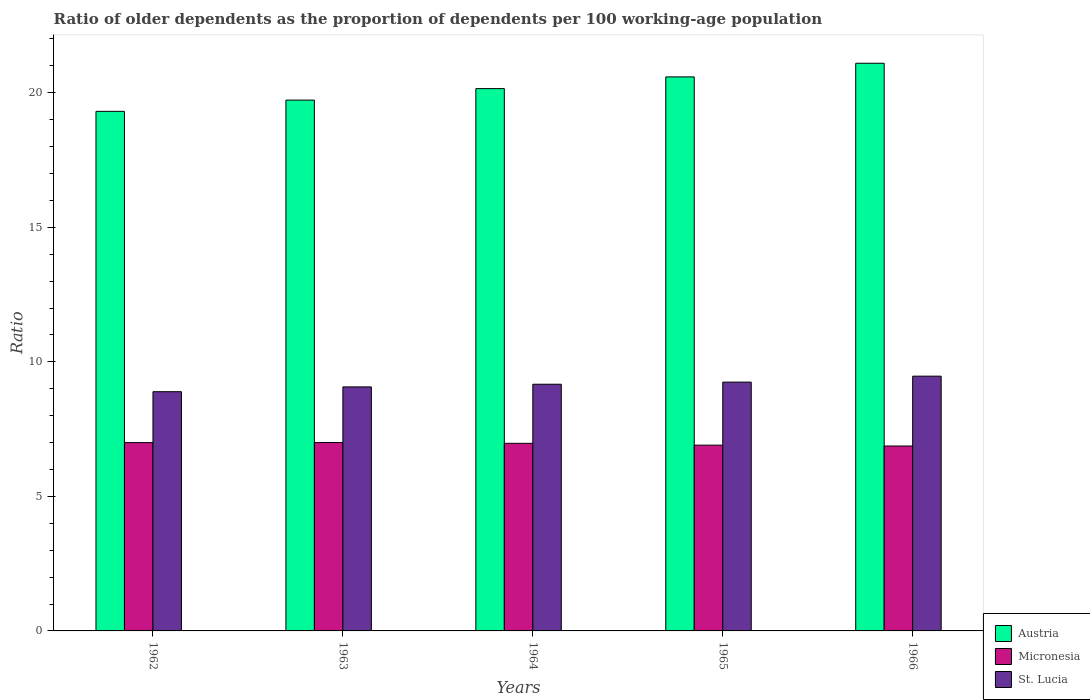How many different coloured bars are there?
Your answer should be very brief. 3. Are the number of bars per tick equal to the number of legend labels?
Offer a very short reply. Yes. Are the number of bars on each tick of the X-axis equal?
Your response must be concise. Yes. How many bars are there on the 2nd tick from the left?
Ensure brevity in your answer.  3. How many bars are there on the 3rd tick from the right?
Provide a short and direct response. 3. What is the label of the 4th group of bars from the left?
Your answer should be compact. 1965. What is the age dependency ratio(old) in Austria in 1965?
Offer a very short reply. 20.59. Across all years, what is the maximum age dependency ratio(old) in Micronesia?
Your answer should be compact. 7. Across all years, what is the minimum age dependency ratio(old) in St. Lucia?
Your answer should be very brief. 8.89. In which year was the age dependency ratio(old) in St. Lucia maximum?
Provide a short and direct response. 1966. What is the total age dependency ratio(old) in Austria in the graph?
Offer a terse response. 100.87. What is the difference between the age dependency ratio(old) in Austria in 1963 and that in 1964?
Ensure brevity in your answer.  -0.43. What is the difference between the age dependency ratio(old) in St. Lucia in 1966 and the age dependency ratio(old) in Austria in 1963?
Provide a short and direct response. -10.26. What is the average age dependency ratio(old) in Micronesia per year?
Your answer should be very brief. 6.95. In the year 1966, what is the difference between the age dependency ratio(old) in Austria and age dependency ratio(old) in Micronesia?
Keep it short and to the point. 14.22. In how many years, is the age dependency ratio(old) in Micronesia greater than 8?
Make the answer very short. 0. What is the ratio of the age dependency ratio(old) in Austria in 1962 to that in 1963?
Provide a short and direct response. 0.98. Is the age dependency ratio(old) in Micronesia in 1964 less than that in 1965?
Offer a terse response. No. Is the difference between the age dependency ratio(old) in Austria in 1964 and 1966 greater than the difference between the age dependency ratio(old) in Micronesia in 1964 and 1966?
Offer a terse response. No. What is the difference between the highest and the second highest age dependency ratio(old) in Micronesia?
Give a very brief answer. 0. What is the difference between the highest and the lowest age dependency ratio(old) in Micronesia?
Make the answer very short. 0.13. What does the 1st bar from the right in 1962 represents?
Make the answer very short. St. Lucia. Is it the case that in every year, the sum of the age dependency ratio(old) in Austria and age dependency ratio(old) in St. Lucia is greater than the age dependency ratio(old) in Micronesia?
Ensure brevity in your answer.  Yes. How many bars are there?
Your answer should be compact. 15. How many years are there in the graph?
Ensure brevity in your answer.  5. What is the difference between two consecutive major ticks on the Y-axis?
Provide a succinct answer. 5. Does the graph contain any zero values?
Ensure brevity in your answer.  No. Does the graph contain grids?
Offer a terse response. No. Where does the legend appear in the graph?
Make the answer very short. Bottom right. How are the legend labels stacked?
Provide a succinct answer. Vertical. What is the title of the graph?
Ensure brevity in your answer.  Ratio of older dependents as the proportion of dependents per 100 working-age population. What is the label or title of the Y-axis?
Ensure brevity in your answer.  Ratio. What is the Ratio in Austria in 1962?
Provide a succinct answer. 19.31. What is the Ratio of Micronesia in 1962?
Your answer should be very brief. 7. What is the Ratio of St. Lucia in 1962?
Ensure brevity in your answer.  8.89. What is the Ratio of Austria in 1963?
Your response must be concise. 19.73. What is the Ratio in Micronesia in 1963?
Your answer should be very brief. 7. What is the Ratio in St. Lucia in 1963?
Keep it short and to the point. 9.07. What is the Ratio of Austria in 1964?
Offer a very short reply. 20.15. What is the Ratio of Micronesia in 1964?
Your answer should be compact. 6.97. What is the Ratio in St. Lucia in 1964?
Provide a succinct answer. 9.17. What is the Ratio in Austria in 1965?
Ensure brevity in your answer.  20.59. What is the Ratio in Micronesia in 1965?
Your answer should be compact. 6.9. What is the Ratio in St. Lucia in 1965?
Keep it short and to the point. 9.25. What is the Ratio in Austria in 1966?
Ensure brevity in your answer.  21.1. What is the Ratio in Micronesia in 1966?
Your response must be concise. 6.87. What is the Ratio in St. Lucia in 1966?
Provide a succinct answer. 9.47. Across all years, what is the maximum Ratio in Austria?
Give a very brief answer. 21.1. Across all years, what is the maximum Ratio in Micronesia?
Ensure brevity in your answer.  7. Across all years, what is the maximum Ratio in St. Lucia?
Your answer should be very brief. 9.47. Across all years, what is the minimum Ratio in Austria?
Your answer should be compact. 19.31. Across all years, what is the minimum Ratio in Micronesia?
Give a very brief answer. 6.87. Across all years, what is the minimum Ratio in St. Lucia?
Your answer should be compact. 8.89. What is the total Ratio of Austria in the graph?
Keep it short and to the point. 100.87. What is the total Ratio of Micronesia in the graph?
Your response must be concise. 34.75. What is the total Ratio in St. Lucia in the graph?
Offer a very short reply. 45.84. What is the difference between the Ratio of Austria in 1962 and that in 1963?
Give a very brief answer. -0.42. What is the difference between the Ratio of Micronesia in 1962 and that in 1963?
Provide a succinct answer. -0. What is the difference between the Ratio of St. Lucia in 1962 and that in 1963?
Your answer should be very brief. -0.18. What is the difference between the Ratio of Austria in 1962 and that in 1964?
Give a very brief answer. -0.84. What is the difference between the Ratio in Micronesia in 1962 and that in 1964?
Your answer should be compact. 0.03. What is the difference between the Ratio of St. Lucia in 1962 and that in 1964?
Give a very brief answer. -0.28. What is the difference between the Ratio of Austria in 1962 and that in 1965?
Offer a terse response. -1.28. What is the difference between the Ratio in Micronesia in 1962 and that in 1965?
Offer a terse response. 0.09. What is the difference between the Ratio in St. Lucia in 1962 and that in 1965?
Make the answer very short. -0.36. What is the difference between the Ratio of Austria in 1962 and that in 1966?
Your response must be concise. -1.79. What is the difference between the Ratio of Micronesia in 1962 and that in 1966?
Your answer should be very brief. 0.13. What is the difference between the Ratio in St. Lucia in 1962 and that in 1966?
Provide a succinct answer. -0.58. What is the difference between the Ratio of Austria in 1963 and that in 1964?
Offer a very short reply. -0.43. What is the difference between the Ratio of Micronesia in 1963 and that in 1964?
Offer a terse response. 0.03. What is the difference between the Ratio in St. Lucia in 1963 and that in 1964?
Give a very brief answer. -0.1. What is the difference between the Ratio of Austria in 1963 and that in 1965?
Ensure brevity in your answer.  -0.86. What is the difference between the Ratio of Micronesia in 1963 and that in 1965?
Make the answer very short. 0.1. What is the difference between the Ratio in St. Lucia in 1963 and that in 1965?
Provide a short and direct response. -0.18. What is the difference between the Ratio of Austria in 1963 and that in 1966?
Your answer should be compact. -1.37. What is the difference between the Ratio in Micronesia in 1963 and that in 1966?
Your answer should be compact. 0.13. What is the difference between the Ratio of St. Lucia in 1963 and that in 1966?
Ensure brevity in your answer.  -0.4. What is the difference between the Ratio in Austria in 1964 and that in 1965?
Make the answer very short. -0.44. What is the difference between the Ratio in Micronesia in 1964 and that in 1965?
Your answer should be very brief. 0.07. What is the difference between the Ratio of St. Lucia in 1964 and that in 1965?
Make the answer very short. -0.08. What is the difference between the Ratio of Austria in 1964 and that in 1966?
Make the answer very short. -0.94. What is the difference between the Ratio of Micronesia in 1964 and that in 1966?
Provide a short and direct response. 0.1. What is the difference between the Ratio in St. Lucia in 1964 and that in 1966?
Your response must be concise. -0.3. What is the difference between the Ratio in Austria in 1965 and that in 1966?
Provide a short and direct response. -0.51. What is the difference between the Ratio in Micronesia in 1965 and that in 1966?
Your response must be concise. 0.03. What is the difference between the Ratio of St. Lucia in 1965 and that in 1966?
Give a very brief answer. -0.22. What is the difference between the Ratio of Austria in 1962 and the Ratio of Micronesia in 1963?
Offer a very short reply. 12.31. What is the difference between the Ratio of Austria in 1962 and the Ratio of St. Lucia in 1963?
Provide a short and direct response. 10.24. What is the difference between the Ratio of Micronesia in 1962 and the Ratio of St. Lucia in 1963?
Provide a short and direct response. -2.07. What is the difference between the Ratio of Austria in 1962 and the Ratio of Micronesia in 1964?
Your answer should be very brief. 12.34. What is the difference between the Ratio in Austria in 1962 and the Ratio in St. Lucia in 1964?
Ensure brevity in your answer.  10.14. What is the difference between the Ratio in Micronesia in 1962 and the Ratio in St. Lucia in 1964?
Offer a very short reply. -2.17. What is the difference between the Ratio in Austria in 1962 and the Ratio in Micronesia in 1965?
Provide a succinct answer. 12.41. What is the difference between the Ratio of Austria in 1962 and the Ratio of St. Lucia in 1965?
Provide a short and direct response. 10.06. What is the difference between the Ratio of Micronesia in 1962 and the Ratio of St. Lucia in 1965?
Offer a terse response. -2.25. What is the difference between the Ratio of Austria in 1962 and the Ratio of Micronesia in 1966?
Provide a succinct answer. 12.44. What is the difference between the Ratio of Austria in 1962 and the Ratio of St. Lucia in 1966?
Offer a terse response. 9.84. What is the difference between the Ratio of Micronesia in 1962 and the Ratio of St. Lucia in 1966?
Provide a succinct answer. -2.47. What is the difference between the Ratio in Austria in 1963 and the Ratio in Micronesia in 1964?
Provide a succinct answer. 12.76. What is the difference between the Ratio in Austria in 1963 and the Ratio in St. Lucia in 1964?
Provide a short and direct response. 10.56. What is the difference between the Ratio in Micronesia in 1963 and the Ratio in St. Lucia in 1964?
Provide a succinct answer. -2.17. What is the difference between the Ratio in Austria in 1963 and the Ratio in Micronesia in 1965?
Keep it short and to the point. 12.82. What is the difference between the Ratio in Austria in 1963 and the Ratio in St. Lucia in 1965?
Your answer should be compact. 10.48. What is the difference between the Ratio of Micronesia in 1963 and the Ratio of St. Lucia in 1965?
Keep it short and to the point. -2.25. What is the difference between the Ratio in Austria in 1963 and the Ratio in Micronesia in 1966?
Provide a short and direct response. 12.85. What is the difference between the Ratio of Austria in 1963 and the Ratio of St. Lucia in 1966?
Offer a terse response. 10.26. What is the difference between the Ratio of Micronesia in 1963 and the Ratio of St. Lucia in 1966?
Ensure brevity in your answer.  -2.47. What is the difference between the Ratio in Austria in 1964 and the Ratio in Micronesia in 1965?
Offer a terse response. 13.25. What is the difference between the Ratio in Austria in 1964 and the Ratio in St. Lucia in 1965?
Make the answer very short. 10.91. What is the difference between the Ratio in Micronesia in 1964 and the Ratio in St. Lucia in 1965?
Offer a terse response. -2.27. What is the difference between the Ratio in Austria in 1964 and the Ratio in Micronesia in 1966?
Provide a short and direct response. 13.28. What is the difference between the Ratio of Austria in 1964 and the Ratio of St. Lucia in 1966?
Offer a very short reply. 10.69. What is the difference between the Ratio in Micronesia in 1964 and the Ratio in St. Lucia in 1966?
Keep it short and to the point. -2.5. What is the difference between the Ratio of Austria in 1965 and the Ratio of Micronesia in 1966?
Offer a terse response. 13.72. What is the difference between the Ratio in Austria in 1965 and the Ratio in St. Lucia in 1966?
Give a very brief answer. 11.12. What is the difference between the Ratio of Micronesia in 1965 and the Ratio of St. Lucia in 1966?
Keep it short and to the point. -2.56. What is the average Ratio in Austria per year?
Provide a short and direct response. 20.17. What is the average Ratio in Micronesia per year?
Provide a succinct answer. 6.95. What is the average Ratio in St. Lucia per year?
Keep it short and to the point. 9.17. In the year 1962, what is the difference between the Ratio in Austria and Ratio in Micronesia?
Ensure brevity in your answer.  12.31. In the year 1962, what is the difference between the Ratio of Austria and Ratio of St. Lucia?
Provide a short and direct response. 10.42. In the year 1962, what is the difference between the Ratio in Micronesia and Ratio in St. Lucia?
Provide a short and direct response. -1.89. In the year 1963, what is the difference between the Ratio in Austria and Ratio in Micronesia?
Make the answer very short. 12.73. In the year 1963, what is the difference between the Ratio in Austria and Ratio in St. Lucia?
Offer a very short reply. 10.66. In the year 1963, what is the difference between the Ratio of Micronesia and Ratio of St. Lucia?
Offer a terse response. -2.07. In the year 1964, what is the difference between the Ratio in Austria and Ratio in Micronesia?
Your answer should be very brief. 13.18. In the year 1964, what is the difference between the Ratio of Austria and Ratio of St. Lucia?
Offer a very short reply. 10.99. In the year 1964, what is the difference between the Ratio in Micronesia and Ratio in St. Lucia?
Keep it short and to the point. -2.2. In the year 1965, what is the difference between the Ratio in Austria and Ratio in Micronesia?
Provide a succinct answer. 13.69. In the year 1965, what is the difference between the Ratio in Austria and Ratio in St. Lucia?
Ensure brevity in your answer.  11.34. In the year 1965, what is the difference between the Ratio in Micronesia and Ratio in St. Lucia?
Your answer should be compact. -2.34. In the year 1966, what is the difference between the Ratio in Austria and Ratio in Micronesia?
Keep it short and to the point. 14.22. In the year 1966, what is the difference between the Ratio in Austria and Ratio in St. Lucia?
Offer a terse response. 11.63. In the year 1966, what is the difference between the Ratio of Micronesia and Ratio of St. Lucia?
Provide a succinct answer. -2.6. What is the ratio of the Ratio of Austria in 1962 to that in 1963?
Keep it short and to the point. 0.98. What is the ratio of the Ratio of St. Lucia in 1962 to that in 1963?
Offer a very short reply. 0.98. What is the ratio of the Ratio of Austria in 1962 to that in 1964?
Make the answer very short. 0.96. What is the ratio of the Ratio of Micronesia in 1962 to that in 1964?
Ensure brevity in your answer.  1. What is the ratio of the Ratio in St. Lucia in 1962 to that in 1964?
Offer a very short reply. 0.97. What is the ratio of the Ratio in Austria in 1962 to that in 1965?
Your response must be concise. 0.94. What is the ratio of the Ratio in Micronesia in 1962 to that in 1965?
Ensure brevity in your answer.  1.01. What is the ratio of the Ratio in St. Lucia in 1962 to that in 1965?
Ensure brevity in your answer.  0.96. What is the ratio of the Ratio of Austria in 1962 to that in 1966?
Provide a short and direct response. 0.92. What is the ratio of the Ratio in Micronesia in 1962 to that in 1966?
Your answer should be compact. 1.02. What is the ratio of the Ratio in St. Lucia in 1962 to that in 1966?
Offer a very short reply. 0.94. What is the ratio of the Ratio of Austria in 1963 to that in 1964?
Provide a succinct answer. 0.98. What is the ratio of the Ratio of Micronesia in 1963 to that in 1964?
Give a very brief answer. 1. What is the ratio of the Ratio in Austria in 1963 to that in 1965?
Provide a short and direct response. 0.96. What is the ratio of the Ratio in Micronesia in 1963 to that in 1965?
Ensure brevity in your answer.  1.01. What is the ratio of the Ratio in St. Lucia in 1963 to that in 1965?
Offer a terse response. 0.98. What is the ratio of the Ratio in Austria in 1963 to that in 1966?
Offer a very short reply. 0.94. What is the ratio of the Ratio in Micronesia in 1963 to that in 1966?
Offer a terse response. 1.02. What is the ratio of the Ratio in St. Lucia in 1963 to that in 1966?
Your answer should be compact. 0.96. What is the ratio of the Ratio in Austria in 1964 to that in 1965?
Make the answer very short. 0.98. What is the ratio of the Ratio of Micronesia in 1964 to that in 1965?
Provide a succinct answer. 1.01. What is the ratio of the Ratio of Austria in 1964 to that in 1966?
Your response must be concise. 0.96. What is the ratio of the Ratio in Micronesia in 1964 to that in 1966?
Your answer should be very brief. 1.01. What is the ratio of the Ratio of St. Lucia in 1964 to that in 1966?
Make the answer very short. 0.97. What is the ratio of the Ratio in St. Lucia in 1965 to that in 1966?
Offer a very short reply. 0.98. What is the difference between the highest and the second highest Ratio in Austria?
Keep it short and to the point. 0.51. What is the difference between the highest and the second highest Ratio of Micronesia?
Keep it short and to the point. 0. What is the difference between the highest and the second highest Ratio in St. Lucia?
Ensure brevity in your answer.  0.22. What is the difference between the highest and the lowest Ratio of Austria?
Offer a terse response. 1.79. What is the difference between the highest and the lowest Ratio of Micronesia?
Ensure brevity in your answer.  0.13. What is the difference between the highest and the lowest Ratio of St. Lucia?
Make the answer very short. 0.58. 